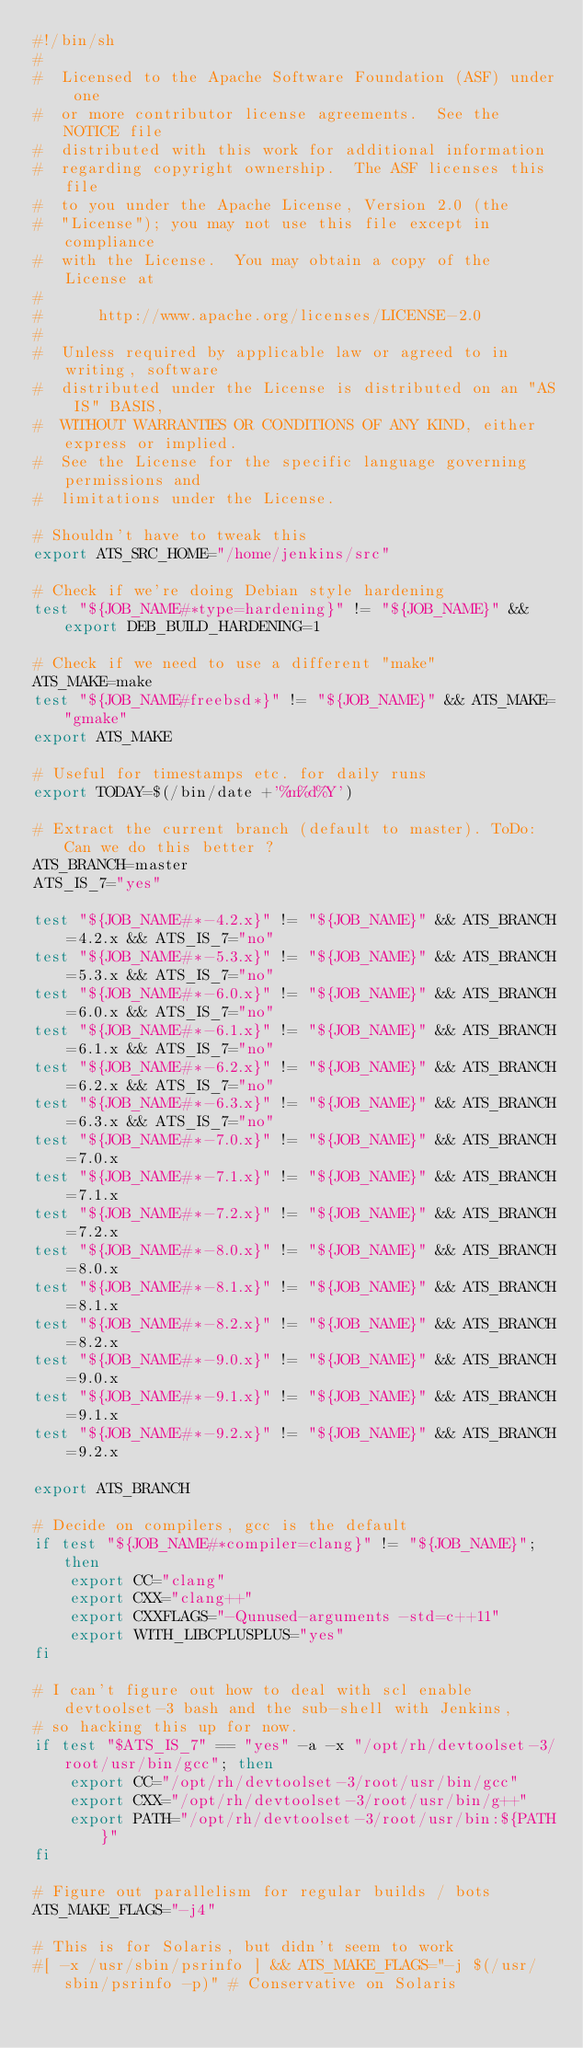<code> <loc_0><loc_0><loc_500><loc_500><_Bash_>#!/bin/sh
#
#  Licensed to the Apache Software Foundation (ASF) under one
#  or more contributor license agreements.  See the NOTICE file
#  distributed with this work for additional information
#  regarding copyright ownership.  The ASF licenses this file
#  to you under the Apache License, Version 2.0 (the
#  "License"); you may not use this file except in compliance
#  with the License.  You may obtain a copy of the License at
#
#      http://www.apache.org/licenses/LICENSE-2.0
#
#  Unless required by applicable law or agreed to in writing, software
#  distributed under the License is distributed on an "AS IS" BASIS,
#  WITHOUT WARRANTIES OR CONDITIONS OF ANY KIND, either express or implied.
#  See the License for the specific language governing permissions and
#  limitations under the License.

# Shouldn't have to tweak this
export ATS_SRC_HOME="/home/jenkins/src"

# Check if we're doing Debian style hardening
test "${JOB_NAME#*type=hardening}" != "${JOB_NAME}" && export DEB_BUILD_HARDENING=1

# Check if we need to use a different "make"
ATS_MAKE=make
test "${JOB_NAME#freebsd*}" != "${JOB_NAME}" && ATS_MAKE="gmake"
export ATS_MAKE

# Useful for timestamps etc. for daily runs
export TODAY=$(/bin/date +'%m%d%Y')

# Extract the current branch (default to master). ToDo: Can we do this better ?
ATS_BRANCH=master
ATS_IS_7="yes"

test "${JOB_NAME#*-4.2.x}" != "${JOB_NAME}" && ATS_BRANCH=4.2.x && ATS_IS_7="no"
test "${JOB_NAME#*-5.3.x}" != "${JOB_NAME}" && ATS_BRANCH=5.3.x && ATS_IS_7="no"
test "${JOB_NAME#*-6.0.x}" != "${JOB_NAME}" && ATS_BRANCH=6.0.x && ATS_IS_7="no"
test "${JOB_NAME#*-6.1.x}" != "${JOB_NAME}" && ATS_BRANCH=6.1.x && ATS_IS_7="no"
test "${JOB_NAME#*-6.2.x}" != "${JOB_NAME}" && ATS_BRANCH=6.2.x && ATS_IS_7="no"
test "${JOB_NAME#*-6.3.x}" != "${JOB_NAME}" && ATS_BRANCH=6.3.x && ATS_IS_7="no"
test "${JOB_NAME#*-7.0.x}" != "${JOB_NAME}" && ATS_BRANCH=7.0.x
test "${JOB_NAME#*-7.1.x}" != "${JOB_NAME}" && ATS_BRANCH=7.1.x
test "${JOB_NAME#*-7.2.x}" != "${JOB_NAME}" && ATS_BRANCH=7.2.x
test "${JOB_NAME#*-8.0.x}" != "${JOB_NAME}" && ATS_BRANCH=8.0.x
test "${JOB_NAME#*-8.1.x}" != "${JOB_NAME}" && ATS_BRANCH=8.1.x
test "${JOB_NAME#*-8.2.x}" != "${JOB_NAME}" && ATS_BRANCH=8.2.x
test "${JOB_NAME#*-9.0.x}" != "${JOB_NAME}" && ATS_BRANCH=9.0.x
test "${JOB_NAME#*-9.1.x}" != "${JOB_NAME}" && ATS_BRANCH=9.1.x
test "${JOB_NAME#*-9.2.x}" != "${JOB_NAME}" && ATS_BRANCH=9.2.x

export ATS_BRANCH

# Decide on compilers, gcc is the default
if test "${JOB_NAME#*compiler=clang}" != "${JOB_NAME}"; then
    export CC="clang"
    export CXX="clang++"
    export CXXFLAGS="-Qunused-arguments -std=c++11"
    export WITH_LIBCPLUSPLUS="yes"
fi

# I can't figure out how to deal with scl enable devtoolset-3 bash and the sub-shell with Jenkins,
# so hacking this up for now.
if test "$ATS_IS_7" == "yes" -a -x "/opt/rh/devtoolset-3/root/usr/bin/gcc"; then
    export CC="/opt/rh/devtoolset-3/root/usr/bin/gcc"
    export CXX="/opt/rh/devtoolset-3/root/usr/bin/g++"
    export PATH="/opt/rh/devtoolset-3/root/usr/bin:${PATH}"
fi

# Figure out parallelism for regular builds / bots
ATS_MAKE_FLAGS="-j4"

# This is for Solaris, but didn't seem to work
#[ -x /usr/sbin/psrinfo ] && ATS_MAKE_FLAGS="-j $(/usr/sbin/psrinfo -p)" # Conservative on Solaris
</code> 